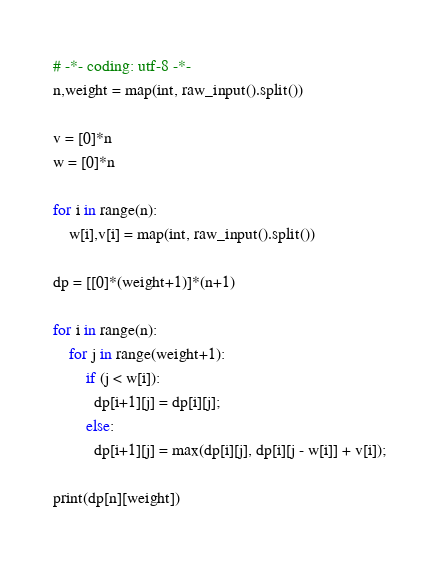Convert code to text. <code><loc_0><loc_0><loc_500><loc_500><_Python_># -*- coding: utf-8 -*-
n,weight = map(int, raw_input().split())

v = [0]*n
w = [0]*n
    
for i in range(n):
    w[i],v[i] = map(int, raw_input().split())

dp = [[0]*(weight+1)]*(n+1)

for i in range(n):
    for j in range(weight+1):
        if (j < w[i]):
          dp[i+1][j] = dp[i][j];
        else:
          dp[i+1][j] = max(dp[i][j], dp[i][j - w[i]] + v[i]);

print(dp[n][weight])

</code> 